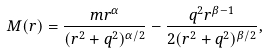<formula> <loc_0><loc_0><loc_500><loc_500>M ( r ) = \frac { m r ^ { \alpha } } { ( r ^ { 2 } + q ^ { 2 } ) ^ { \alpha / 2 } } - \frac { q ^ { 2 } r ^ { \beta - 1 } } { 2 ( r ^ { 2 } + q ^ { 2 } ) ^ { \beta / 2 } } ,</formula> 